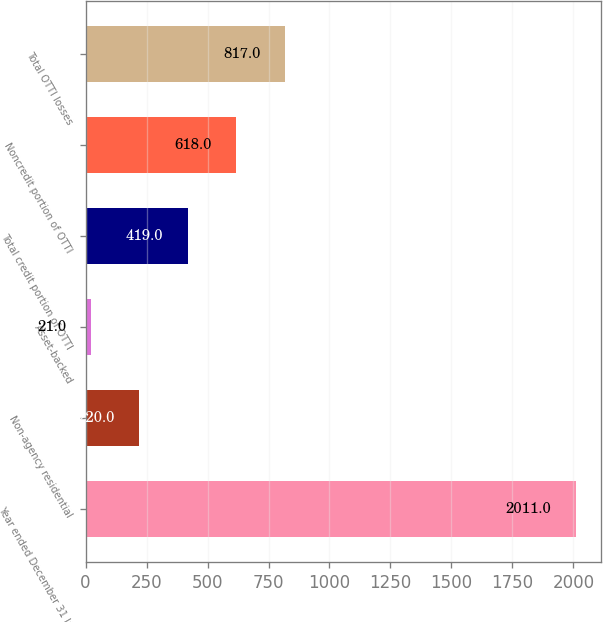Convert chart to OTSL. <chart><loc_0><loc_0><loc_500><loc_500><bar_chart><fcel>Year ended December 31 In<fcel>Non-agency residential<fcel>Asset-backed<fcel>Total credit portion of OTTI<fcel>Noncredit portion of OTTI<fcel>Total OTTI losses<nl><fcel>2011<fcel>220<fcel>21<fcel>419<fcel>618<fcel>817<nl></chart> 